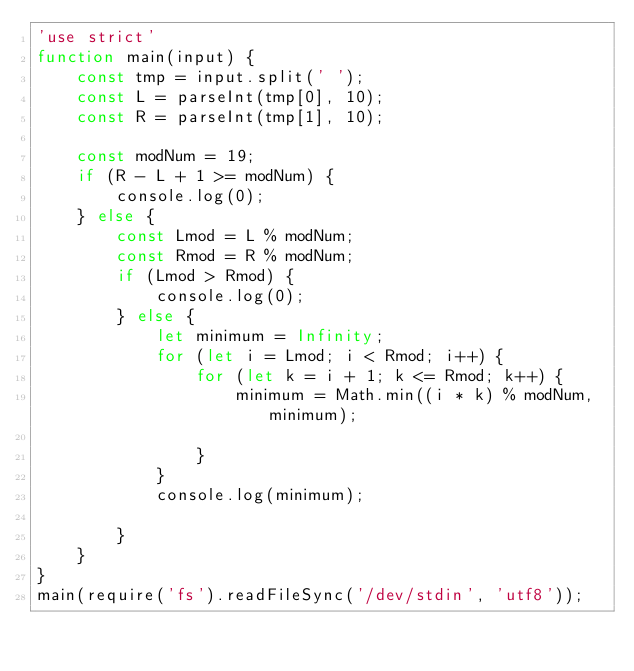<code> <loc_0><loc_0><loc_500><loc_500><_JavaScript_>'use strict'
function main(input) {
    const tmp = input.split(' ');
    const L = parseInt(tmp[0], 10);
    const R = parseInt(tmp[1], 10);

    const modNum = 19;
    if (R - L + 1 >= modNum) {
        console.log(0);
    } else {
        const Lmod = L % modNum;
        const Rmod = R % modNum;
        if (Lmod > Rmod) {
            console.log(0);
        } else {
            let minimum = Infinity;
            for (let i = Lmod; i < Rmod; i++) {
                for (let k = i + 1; k <= Rmod; k++) {
                    minimum = Math.min((i * k) % modNum, minimum);

                }
            }
            console.log(minimum);

        }
    }
}
main(require('fs').readFileSync('/dev/stdin', 'utf8'));</code> 